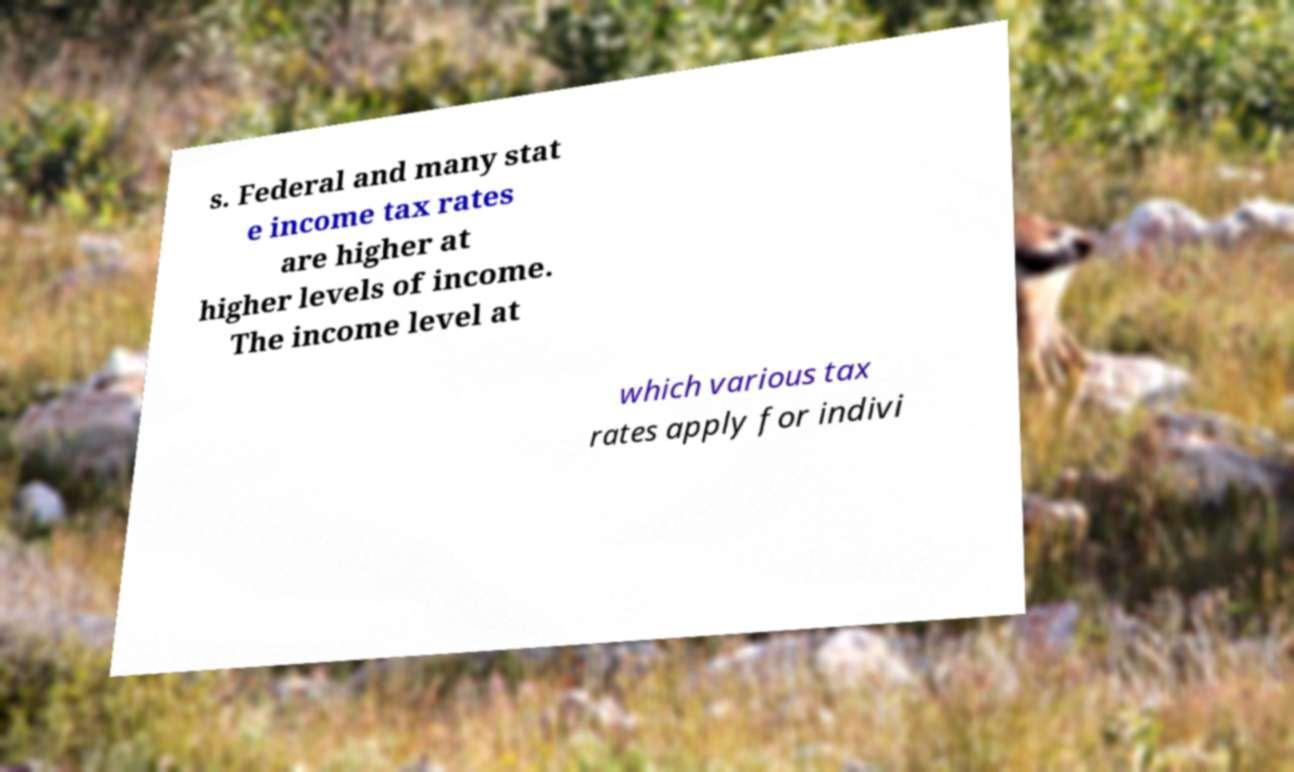I need the written content from this picture converted into text. Can you do that? s. Federal and many stat e income tax rates are higher at higher levels of income. The income level at which various tax rates apply for indivi 